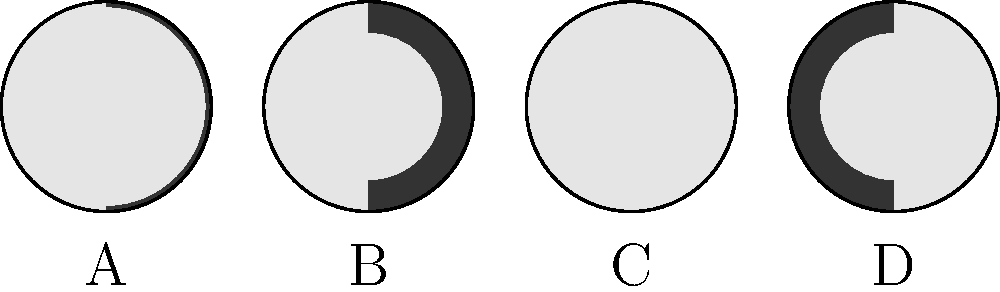In our virtual book club, we're discussing a novel that uses lunar phases as a metaphor. To enhance our understanding, can you identify which diagram represents the First Quarter Moon phase? Let's analyze each diagram to determine which one represents the First Quarter Moon:

1. Diagram A: This shows a thin crescent on the right side of the moon. This represents a Waxing Crescent phase, which occurs before the First Quarter.

2. Diagram B: Here, exactly half of the moon's visible surface is illuminated on the right side. This is the First Quarter Moon phase.

3. Diagram C: This diagram shows a fully illuminated half-circle on the right side of the moon, with the left side completely dark. This represents the Full Moon phase.

4. Diagram D: This shows a half-circle illuminated on the left side of the moon. This represents the Last Quarter Moon phase.

The First Quarter Moon occurs when the moon has completed one-quarter of its orbit around the Earth, and half of its visible surface is illuminated from our perspective on Earth. This corresponds exactly to Diagram B.
Answer: B 